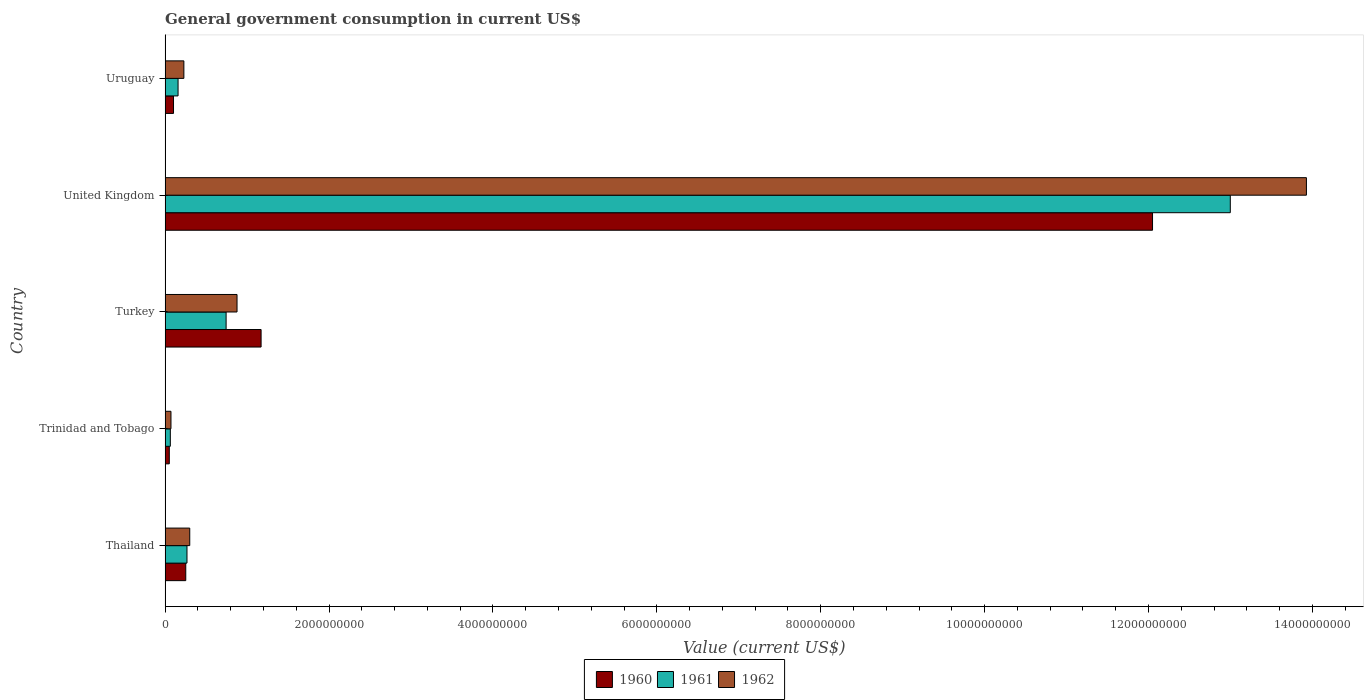How many different coloured bars are there?
Your response must be concise. 3. How many groups of bars are there?
Keep it short and to the point. 5. Are the number of bars per tick equal to the number of legend labels?
Offer a terse response. Yes. Are the number of bars on each tick of the Y-axis equal?
Provide a succinct answer. Yes. How many bars are there on the 5th tick from the bottom?
Provide a succinct answer. 3. What is the label of the 1st group of bars from the top?
Offer a terse response. Uruguay. What is the government conusmption in 1960 in Thailand?
Provide a succinct answer. 2.52e+08. Across all countries, what is the maximum government conusmption in 1960?
Make the answer very short. 1.20e+1. Across all countries, what is the minimum government conusmption in 1962?
Make the answer very short. 7.16e+07. In which country was the government conusmption in 1962 maximum?
Provide a short and direct response. United Kingdom. In which country was the government conusmption in 1960 minimum?
Make the answer very short. Trinidad and Tobago. What is the total government conusmption in 1961 in the graph?
Your response must be concise. 1.42e+1. What is the difference between the government conusmption in 1960 in Trinidad and Tobago and that in Uruguay?
Give a very brief answer. -5.16e+07. What is the difference between the government conusmption in 1960 in Thailand and the government conusmption in 1961 in Trinidad and Tobago?
Your answer should be compact. 1.88e+08. What is the average government conusmption in 1961 per country?
Offer a terse response. 2.85e+09. What is the difference between the government conusmption in 1962 and government conusmption in 1961 in Thailand?
Keep it short and to the point. 3.36e+07. What is the ratio of the government conusmption in 1961 in Thailand to that in Trinidad and Tobago?
Provide a succinct answer. 4.18. Is the difference between the government conusmption in 1962 in Trinidad and Tobago and United Kingdom greater than the difference between the government conusmption in 1961 in Trinidad and Tobago and United Kingdom?
Keep it short and to the point. No. What is the difference between the highest and the second highest government conusmption in 1960?
Provide a succinct answer. 1.09e+1. What is the difference between the highest and the lowest government conusmption in 1962?
Your response must be concise. 1.39e+1. In how many countries, is the government conusmption in 1961 greater than the average government conusmption in 1961 taken over all countries?
Offer a terse response. 1. Is the sum of the government conusmption in 1961 in Turkey and Uruguay greater than the maximum government conusmption in 1962 across all countries?
Ensure brevity in your answer.  No. What does the 3rd bar from the top in Thailand represents?
Offer a very short reply. 1960. What does the 2nd bar from the bottom in Uruguay represents?
Offer a very short reply. 1961. Is it the case that in every country, the sum of the government conusmption in 1962 and government conusmption in 1961 is greater than the government conusmption in 1960?
Provide a succinct answer. Yes. Are all the bars in the graph horizontal?
Provide a succinct answer. Yes. What is the difference between two consecutive major ticks on the X-axis?
Provide a short and direct response. 2.00e+09. Where does the legend appear in the graph?
Ensure brevity in your answer.  Bottom center. How are the legend labels stacked?
Offer a very short reply. Horizontal. What is the title of the graph?
Give a very brief answer. General government consumption in current US$. What is the label or title of the X-axis?
Give a very brief answer. Value (current US$). What is the Value (current US$) in 1960 in Thailand?
Give a very brief answer. 2.52e+08. What is the Value (current US$) of 1961 in Thailand?
Make the answer very short. 2.67e+08. What is the Value (current US$) of 1962 in Thailand?
Your answer should be compact. 3.01e+08. What is the Value (current US$) of 1960 in Trinidad and Tobago?
Your answer should be very brief. 5.12e+07. What is the Value (current US$) in 1961 in Trinidad and Tobago?
Your answer should be very brief. 6.39e+07. What is the Value (current US$) in 1962 in Trinidad and Tobago?
Make the answer very short. 7.16e+07. What is the Value (current US$) of 1960 in Turkey?
Ensure brevity in your answer.  1.17e+09. What is the Value (current US$) of 1961 in Turkey?
Your response must be concise. 7.44e+08. What is the Value (current US$) of 1962 in Turkey?
Ensure brevity in your answer.  8.78e+08. What is the Value (current US$) of 1960 in United Kingdom?
Your response must be concise. 1.20e+1. What is the Value (current US$) in 1961 in United Kingdom?
Keep it short and to the point. 1.30e+1. What is the Value (current US$) in 1962 in United Kingdom?
Offer a very short reply. 1.39e+1. What is the Value (current US$) in 1960 in Uruguay?
Provide a succinct answer. 1.03e+08. What is the Value (current US$) in 1961 in Uruguay?
Provide a short and direct response. 1.58e+08. What is the Value (current US$) in 1962 in Uruguay?
Ensure brevity in your answer.  2.29e+08. Across all countries, what is the maximum Value (current US$) of 1960?
Give a very brief answer. 1.20e+1. Across all countries, what is the maximum Value (current US$) of 1961?
Offer a very short reply. 1.30e+1. Across all countries, what is the maximum Value (current US$) of 1962?
Ensure brevity in your answer.  1.39e+1. Across all countries, what is the minimum Value (current US$) of 1960?
Ensure brevity in your answer.  5.12e+07. Across all countries, what is the minimum Value (current US$) of 1961?
Your response must be concise. 6.39e+07. Across all countries, what is the minimum Value (current US$) of 1962?
Your response must be concise. 7.16e+07. What is the total Value (current US$) in 1960 in the graph?
Ensure brevity in your answer.  1.36e+1. What is the total Value (current US$) of 1961 in the graph?
Offer a very short reply. 1.42e+1. What is the total Value (current US$) in 1962 in the graph?
Offer a terse response. 1.54e+1. What is the difference between the Value (current US$) in 1960 in Thailand and that in Trinidad and Tobago?
Make the answer very short. 2.01e+08. What is the difference between the Value (current US$) of 1961 in Thailand and that in Trinidad and Tobago?
Offer a very short reply. 2.03e+08. What is the difference between the Value (current US$) in 1962 in Thailand and that in Trinidad and Tobago?
Provide a succinct answer. 2.29e+08. What is the difference between the Value (current US$) in 1960 in Thailand and that in Turkey?
Your response must be concise. -9.19e+08. What is the difference between the Value (current US$) of 1961 in Thailand and that in Turkey?
Provide a succinct answer. -4.77e+08. What is the difference between the Value (current US$) in 1962 in Thailand and that in Turkey?
Ensure brevity in your answer.  -5.77e+08. What is the difference between the Value (current US$) of 1960 in Thailand and that in United Kingdom?
Ensure brevity in your answer.  -1.18e+1. What is the difference between the Value (current US$) in 1961 in Thailand and that in United Kingdom?
Provide a short and direct response. -1.27e+1. What is the difference between the Value (current US$) in 1962 in Thailand and that in United Kingdom?
Ensure brevity in your answer.  -1.36e+1. What is the difference between the Value (current US$) of 1960 in Thailand and that in Uruguay?
Keep it short and to the point. 1.49e+08. What is the difference between the Value (current US$) of 1961 in Thailand and that in Uruguay?
Provide a succinct answer. 1.09e+08. What is the difference between the Value (current US$) of 1962 in Thailand and that in Uruguay?
Your answer should be very brief. 7.16e+07. What is the difference between the Value (current US$) in 1960 in Trinidad and Tobago and that in Turkey?
Offer a very short reply. -1.12e+09. What is the difference between the Value (current US$) in 1961 in Trinidad and Tobago and that in Turkey?
Your response must be concise. -6.81e+08. What is the difference between the Value (current US$) of 1962 in Trinidad and Tobago and that in Turkey?
Give a very brief answer. -8.06e+08. What is the difference between the Value (current US$) of 1960 in Trinidad and Tobago and that in United Kingdom?
Offer a terse response. -1.20e+1. What is the difference between the Value (current US$) in 1961 in Trinidad and Tobago and that in United Kingdom?
Provide a succinct answer. -1.29e+1. What is the difference between the Value (current US$) in 1962 in Trinidad and Tobago and that in United Kingdom?
Provide a short and direct response. -1.39e+1. What is the difference between the Value (current US$) in 1960 in Trinidad and Tobago and that in Uruguay?
Provide a short and direct response. -5.16e+07. What is the difference between the Value (current US$) in 1961 in Trinidad and Tobago and that in Uruguay?
Keep it short and to the point. -9.44e+07. What is the difference between the Value (current US$) of 1962 in Trinidad and Tobago and that in Uruguay?
Offer a terse response. -1.58e+08. What is the difference between the Value (current US$) of 1960 in Turkey and that in United Kingdom?
Your response must be concise. -1.09e+1. What is the difference between the Value (current US$) in 1961 in Turkey and that in United Kingdom?
Offer a very short reply. -1.23e+1. What is the difference between the Value (current US$) of 1962 in Turkey and that in United Kingdom?
Provide a succinct answer. -1.30e+1. What is the difference between the Value (current US$) of 1960 in Turkey and that in Uruguay?
Your response must be concise. 1.07e+09. What is the difference between the Value (current US$) in 1961 in Turkey and that in Uruguay?
Give a very brief answer. 5.86e+08. What is the difference between the Value (current US$) of 1962 in Turkey and that in Uruguay?
Ensure brevity in your answer.  6.49e+08. What is the difference between the Value (current US$) in 1960 in United Kingdom and that in Uruguay?
Keep it short and to the point. 1.19e+1. What is the difference between the Value (current US$) in 1961 in United Kingdom and that in Uruguay?
Give a very brief answer. 1.28e+1. What is the difference between the Value (current US$) of 1962 in United Kingdom and that in Uruguay?
Provide a succinct answer. 1.37e+1. What is the difference between the Value (current US$) of 1960 in Thailand and the Value (current US$) of 1961 in Trinidad and Tobago?
Ensure brevity in your answer.  1.88e+08. What is the difference between the Value (current US$) in 1960 in Thailand and the Value (current US$) in 1962 in Trinidad and Tobago?
Keep it short and to the point. 1.81e+08. What is the difference between the Value (current US$) of 1961 in Thailand and the Value (current US$) of 1962 in Trinidad and Tobago?
Your answer should be compact. 1.96e+08. What is the difference between the Value (current US$) of 1960 in Thailand and the Value (current US$) of 1961 in Turkey?
Offer a terse response. -4.92e+08. What is the difference between the Value (current US$) of 1960 in Thailand and the Value (current US$) of 1962 in Turkey?
Offer a very short reply. -6.26e+08. What is the difference between the Value (current US$) of 1961 in Thailand and the Value (current US$) of 1962 in Turkey?
Provide a short and direct response. -6.11e+08. What is the difference between the Value (current US$) of 1960 in Thailand and the Value (current US$) of 1961 in United Kingdom?
Ensure brevity in your answer.  -1.27e+1. What is the difference between the Value (current US$) of 1960 in Thailand and the Value (current US$) of 1962 in United Kingdom?
Provide a succinct answer. -1.37e+1. What is the difference between the Value (current US$) in 1961 in Thailand and the Value (current US$) in 1962 in United Kingdom?
Make the answer very short. -1.37e+1. What is the difference between the Value (current US$) of 1960 in Thailand and the Value (current US$) of 1961 in Uruguay?
Provide a succinct answer. 9.39e+07. What is the difference between the Value (current US$) of 1960 in Thailand and the Value (current US$) of 1962 in Uruguay?
Keep it short and to the point. 2.30e+07. What is the difference between the Value (current US$) of 1961 in Thailand and the Value (current US$) of 1962 in Uruguay?
Ensure brevity in your answer.  3.80e+07. What is the difference between the Value (current US$) of 1960 in Trinidad and Tobago and the Value (current US$) of 1961 in Turkey?
Provide a succinct answer. -6.93e+08. What is the difference between the Value (current US$) of 1960 in Trinidad and Tobago and the Value (current US$) of 1962 in Turkey?
Provide a short and direct response. -8.27e+08. What is the difference between the Value (current US$) in 1961 in Trinidad and Tobago and the Value (current US$) in 1962 in Turkey?
Make the answer very short. -8.14e+08. What is the difference between the Value (current US$) in 1960 in Trinidad and Tobago and the Value (current US$) in 1961 in United Kingdom?
Provide a short and direct response. -1.29e+1. What is the difference between the Value (current US$) in 1960 in Trinidad and Tobago and the Value (current US$) in 1962 in United Kingdom?
Your answer should be compact. -1.39e+1. What is the difference between the Value (current US$) of 1961 in Trinidad and Tobago and the Value (current US$) of 1962 in United Kingdom?
Provide a succinct answer. -1.39e+1. What is the difference between the Value (current US$) of 1960 in Trinidad and Tobago and the Value (current US$) of 1961 in Uruguay?
Keep it short and to the point. -1.07e+08. What is the difference between the Value (current US$) of 1960 in Trinidad and Tobago and the Value (current US$) of 1962 in Uruguay?
Your answer should be very brief. -1.78e+08. What is the difference between the Value (current US$) in 1961 in Trinidad and Tobago and the Value (current US$) in 1962 in Uruguay?
Provide a short and direct response. -1.65e+08. What is the difference between the Value (current US$) of 1960 in Turkey and the Value (current US$) of 1961 in United Kingdom?
Your answer should be very brief. -1.18e+1. What is the difference between the Value (current US$) of 1960 in Turkey and the Value (current US$) of 1962 in United Kingdom?
Your response must be concise. -1.28e+1. What is the difference between the Value (current US$) in 1961 in Turkey and the Value (current US$) in 1962 in United Kingdom?
Your answer should be very brief. -1.32e+1. What is the difference between the Value (current US$) of 1960 in Turkey and the Value (current US$) of 1961 in Uruguay?
Make the answer very short. 1.01e+09. What is the difference between the Value (current US$) in 1960 in Turkey and the Value (current US$) in 1962 in Uruguay?
Your answer should be compact. 9.42e+08. What is the difference between the Value (current US$) of 1961 in Turkey and the Value (current US$) of 1962 in Uruguay?
Your response must be concise. 5.15e+08. What is the difference between the Value (current US$) of 1960 in United Kingdom and the Value (current US$) of 1961 in Uruguay?
Give a very brief answer. 1.19e+1. What is the difference between the Value (current US$) of 1960 in United Kingdom and the Value (current US$) of 1962 in Uruguay?
Your answer should be compact. 1.18e+1. What is the difference between the Value (current US$) of 1961 in United Kingdom and the Value (current US$) of 1962 in Uruguay?
Your response must be concise. 1.28e+1. What is the average Value (current US$) of 1960 per country?
Keep it short and to the point. 2.73e+09. What is the average Value (current US$) in 1961 per country?
Make the answer very short. 2.85e+09. What is the average Value (current US$) of 1962 per country?
Provide a short and direct response. 3.08e+09. What is the difference between the Value (current US$) in 1960 and Value (current US$) in 1961 in Thailand?
Provide a short and direct response. -1.50e+07. What is the difference between the Value (current US$) of 1960 and Value (current US$) of 1962 in Thailand?
Offer a terse response. -4.86e+07. What is the difference between the Value (current US$) of 1961 and Value (current US$) of 1962 in Thailand?
Your answer should be compact. -3.36e+07. What is the difference between the Value (current US$) of 1960 and Value (current US$) of 1961 in Trinidad and Tobago?
Offer a very short reply. -1.27e+07. What is the difference between the Value (current US$) of 1960 and Value (current US$) of 1962 in Trinidad and Tobago?
Make the answer very short. -2.04e+07. What is the difference between the Value (current US$) in 1961 and Value (current US$) in 1962 in Trinidad and Tobago?
Offer a terse response. -7.70e+06. What is the difference between the Value (current US$) of 1960 and Value (current US$) of 1961 in Turkey?
Your response must be concise. 4.27e+08. What is the difference between the Value (current US$) in 1960 and Value (current US$) in 1962 in Turkey?
Make the answer very short. 2.94e+08. What is the difference between the Value (current US$) in 1961 and Value (current US$) in 1962 in Turkey?
Provide a succinct answer. -1.33e+08. What is the difference between the Value (current US$) in 1960 and Value (current US$) in 1961 in United Kingdom?
Your answer should be compact. -9.49e+08. What is the difference between the Value (current US$) of 1960 and Value (current US$) of 1962 in United Kingdom?
Ensure brevity in your answer.  -1.88e+09. What is the difference between the Value (current US$) in 1961 and Value (current US$) in 1962 in United Kingdom?
Provide a succinct answer. -9.29e+08. What is the difference between the Value (current US$) of 1960 and Value (current US$) of 1961 in Uruguay?
Ensure brevity in your answer.  -5.54e+07. What is the difference between the Value (current US$) of 1960 and Value (current US$) of 1962 in Uruguay?
Your answer should be compact. -1.26e+08. What is the difference between the Value (current US$) of 1961 and Value (current US$) of 1962 in Uruguay?
Your response must be concise. -7.09e+07. What is the ratio of the Value (current US$) in 1960 in Thailand to that in Trinidad and Tobago?
Make the answer very short. 4.92. What is the ratio of the Value (current US$) of 1961 in Thailand to that in Trinidad and Tobago?
Your answer should be compact. 4.18. What is the ratio of the Value (current US$) in 1962 in Thailand to that in Trinidad and Tobago?
Offer a very short reply. 4.2. What is the ratio of the Value (current US$) in 1960 in Thailand to that in Turkey?
Make the answer very short. 0.22. What is the ratio of the Value (current US$) in 1961 in Thailand to that in Turkey?
Provide a short and direct response. 0.36. What is the ratio of the Value (current US$) of 1962 in Thailand to that in Turkey?
Your answer should be compact. 0.34. What is the ratio of the Value (current US$) of 1960 in Thailand to that in United Kingdom?
Give a very brief answer. 0.02. What is the ratio of the Value (current US$) of 1961 in Thailand to that in United Kingdom?
Offer a very short reply. 0.02. What is the ratio of the Value (current US$) of 1962 in Thailand to that in United Kingdom?
Your answer should be very brief. 0.02. What is the ratio of the Value (current US$) in 1960 in Thailand to that in Uruguay?
Provide a short and direct response. 2.45. What is the ratio of the Value (current US$) of 1961 in Thailand to that in Uruguay?
Your response must be concise. 1.69. What is the ratio of the Value (current US$) in 1962 in Thailand to that in Uruguay?
Give a very brief answer. 1.31. What is the ratio of the Value (current US$) in 1960 in Trinidad and Tobago to that in Turkey?
Your response must be concise. 0.04. What is the ratio of the Value (current US$) of 1961 in Trinidad and Tobago to that in Turkey?
Provide a short and direct response. 0.09. What is the ratio of the Value (current US$) in 1962 in Trinidad and Tobago to that in Turkey?
Ensure brevity in your answer.  0.08. What is the ratio of the Value (current US$) in 1960 in Trinidad and Tobago to that in United Kingdom?
Offer a terse response. 0. What is the ratio of the Value (current US$) of 1961 in Trinidad and Tobago to that in United Kingdom?
Offer a very short reply. 0. What is the ratio of the Value (current US$) of 1962 in Trinidad and Tobago to that in United Kingdom?
Your answer should be very brief. 0.01. What is the ratio of the Value (current US$) of 1960 in Trinidad and Tobago to that in Uruguay?
Make the answer very short. 0.5. What is the ratio of the Value (current US$) in 1961 in Trinidad and Tobago to that in Uruguay?
Make the answer very short. 0.4. What is the ratio of the Value (current US$) of 1962 in Trinidad and Tobago to that in Uruguay?
Offer a terse response. 0.31. What is the ratio of the Value (current US$) in 1960 in Turkey to that in United Kingdom?
Offer a terse response. 0.1. What is the ratio of the Value (current US$) in 1961 in Turkey to that in United Kingdom?
Provide a succinct answer. 0.06. What is the ratio of the Value (current US$) in 1962 in Turkey to that in United Kingdom?
Provide a short and direct response. 0.06. What is the ratio of the Value (current US$) of 1960 in Turkey to that in Uruguay?
Ensure brevity in your answer.  11.39. What is the ratio of the Value (current US$) in 1961 in Turkey to that in Uruguay?
Your answer should be compact. 4.7. What is the ratio of the Value (current US$) of 1962 in Turkey to that in Uruguay?
Keep it short and to the point. 3.83. What is the ratio of the Value (current US$) in 1960 in United Kingdom to that in Uruguay?
Your answer should be compact. 117.2. What is the ratio of the Value (current US$) of 1961 in United Kingdom to that in Uruguay?
Give a very brief answer. 82.14. What is the ratio of the Value (current US$) in 1962 in United Kingdom to that in Uruguay?
Provide a short and direct response. 60.77. What is the difference between the highest and the second highest Value (current US$) of 1960?
Your answer should be compact. 1.09e+1. What is the difference between the highest and the second highest Value (current US$) of 1961?
Offer a terse response. 1.23e+1. What is the difference between the highest and the second highest Value (current US$) in 1962?
Offer a terse response. 1.30e+1. What is the difference between the highest and the lowest Value (current US$) in 1960?
Keep it short and to the point. 1.20e+1. What is the difference between the highest and the lowest Value (current US$) of 1961?
Keep it short and to the point. 1.29e+1. What is the difference between the highest and the lowest Value (current US$) of 1962?
Make the answer very short. 1.39e+1. 